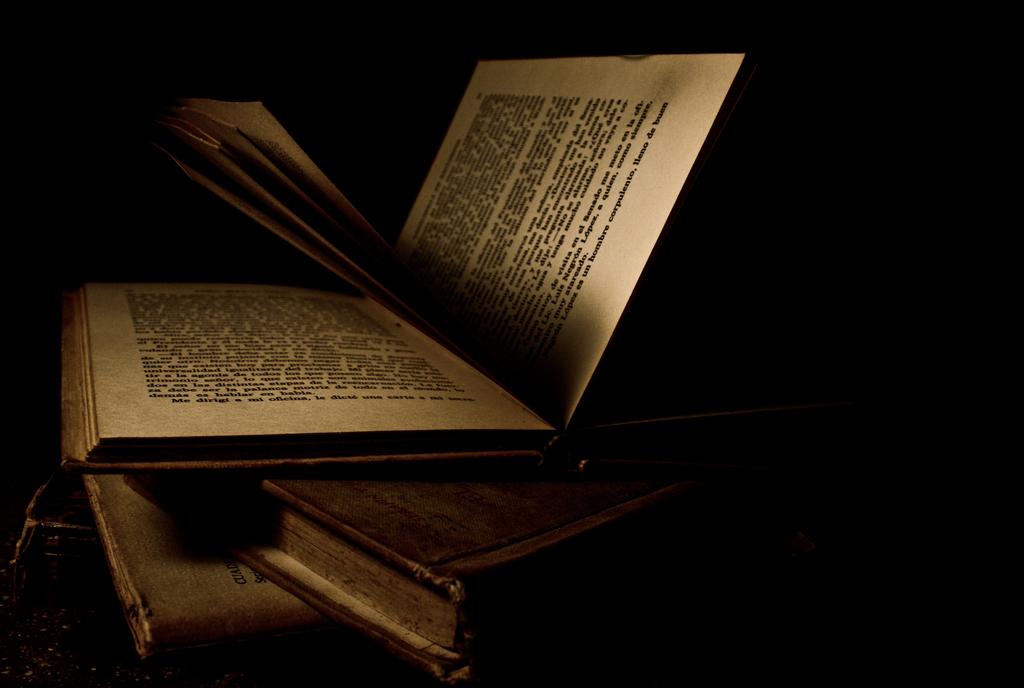This is a television?
Make the answer very short. No. 